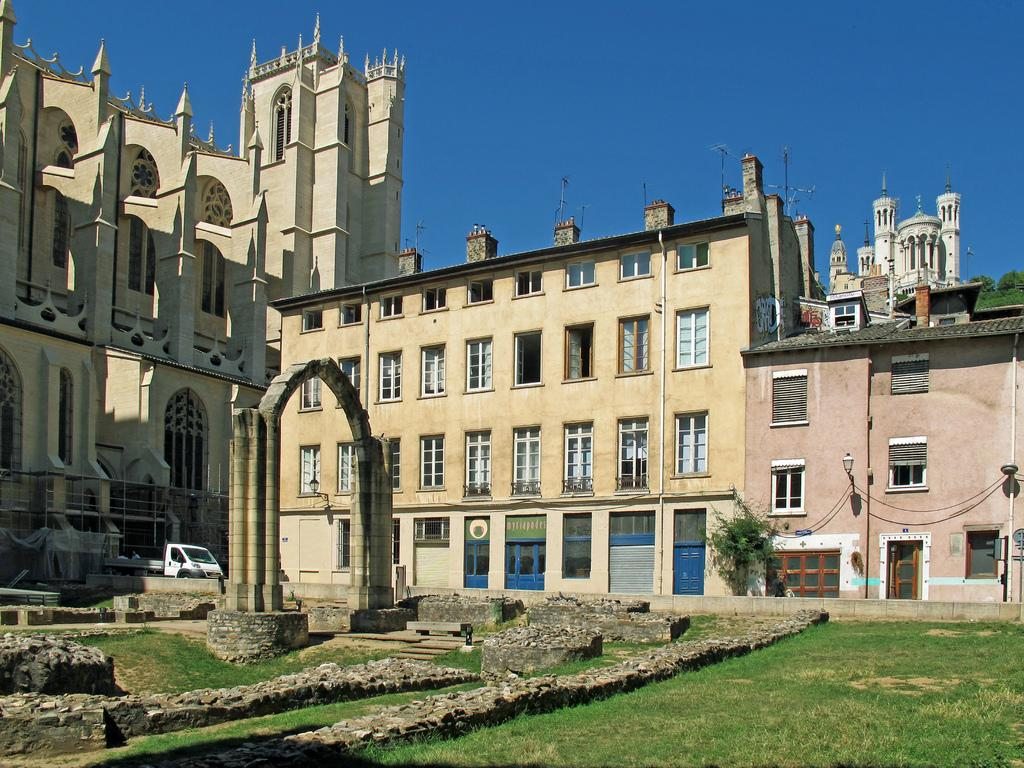What type of natural environment is visible in the image? There is grass in the image, which suggests a natural environment. What type of man-made structure can be seen in the image? There is a vehicle in the image, which is a man-made structure. What type of buildings can be seen in the image? There are buildings in the image. What type of architectural feature can be seen in the image? There is a street lamp in the image. What is visible in the sky in the image? The sky is visible in the image. Can you tell me how many squirrels are sitting on the square in the image? There are no squirrels or squares present in the image. What type of man is depicted interacting with the street lamp in the image? There is no man depicted interacting with the street lamp in the image; only the street lamp and other objects are present. 